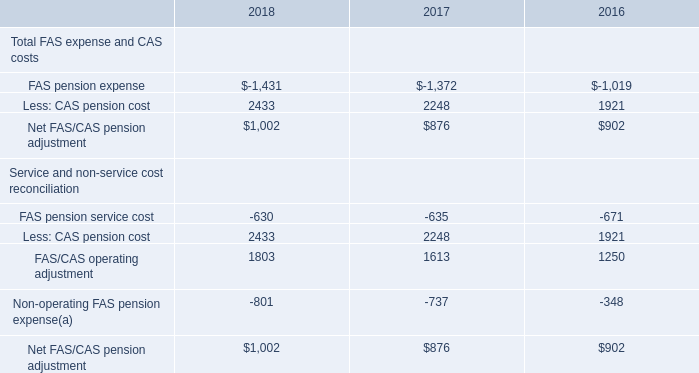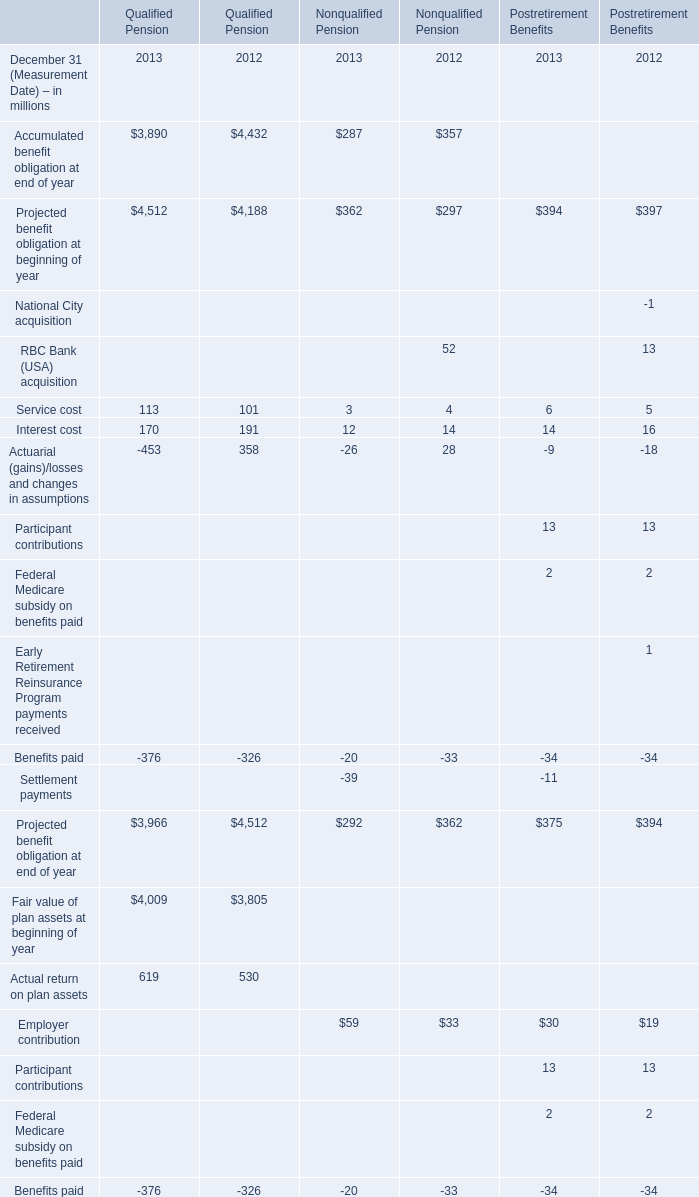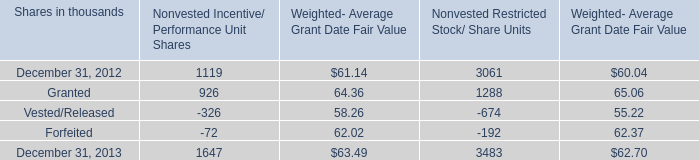What was the total amount of Qualified Pension greater than 4000 in 2013? (in million) 
Computations: ((4512 + 4009) + 4252)
Answer: 12773.0. 